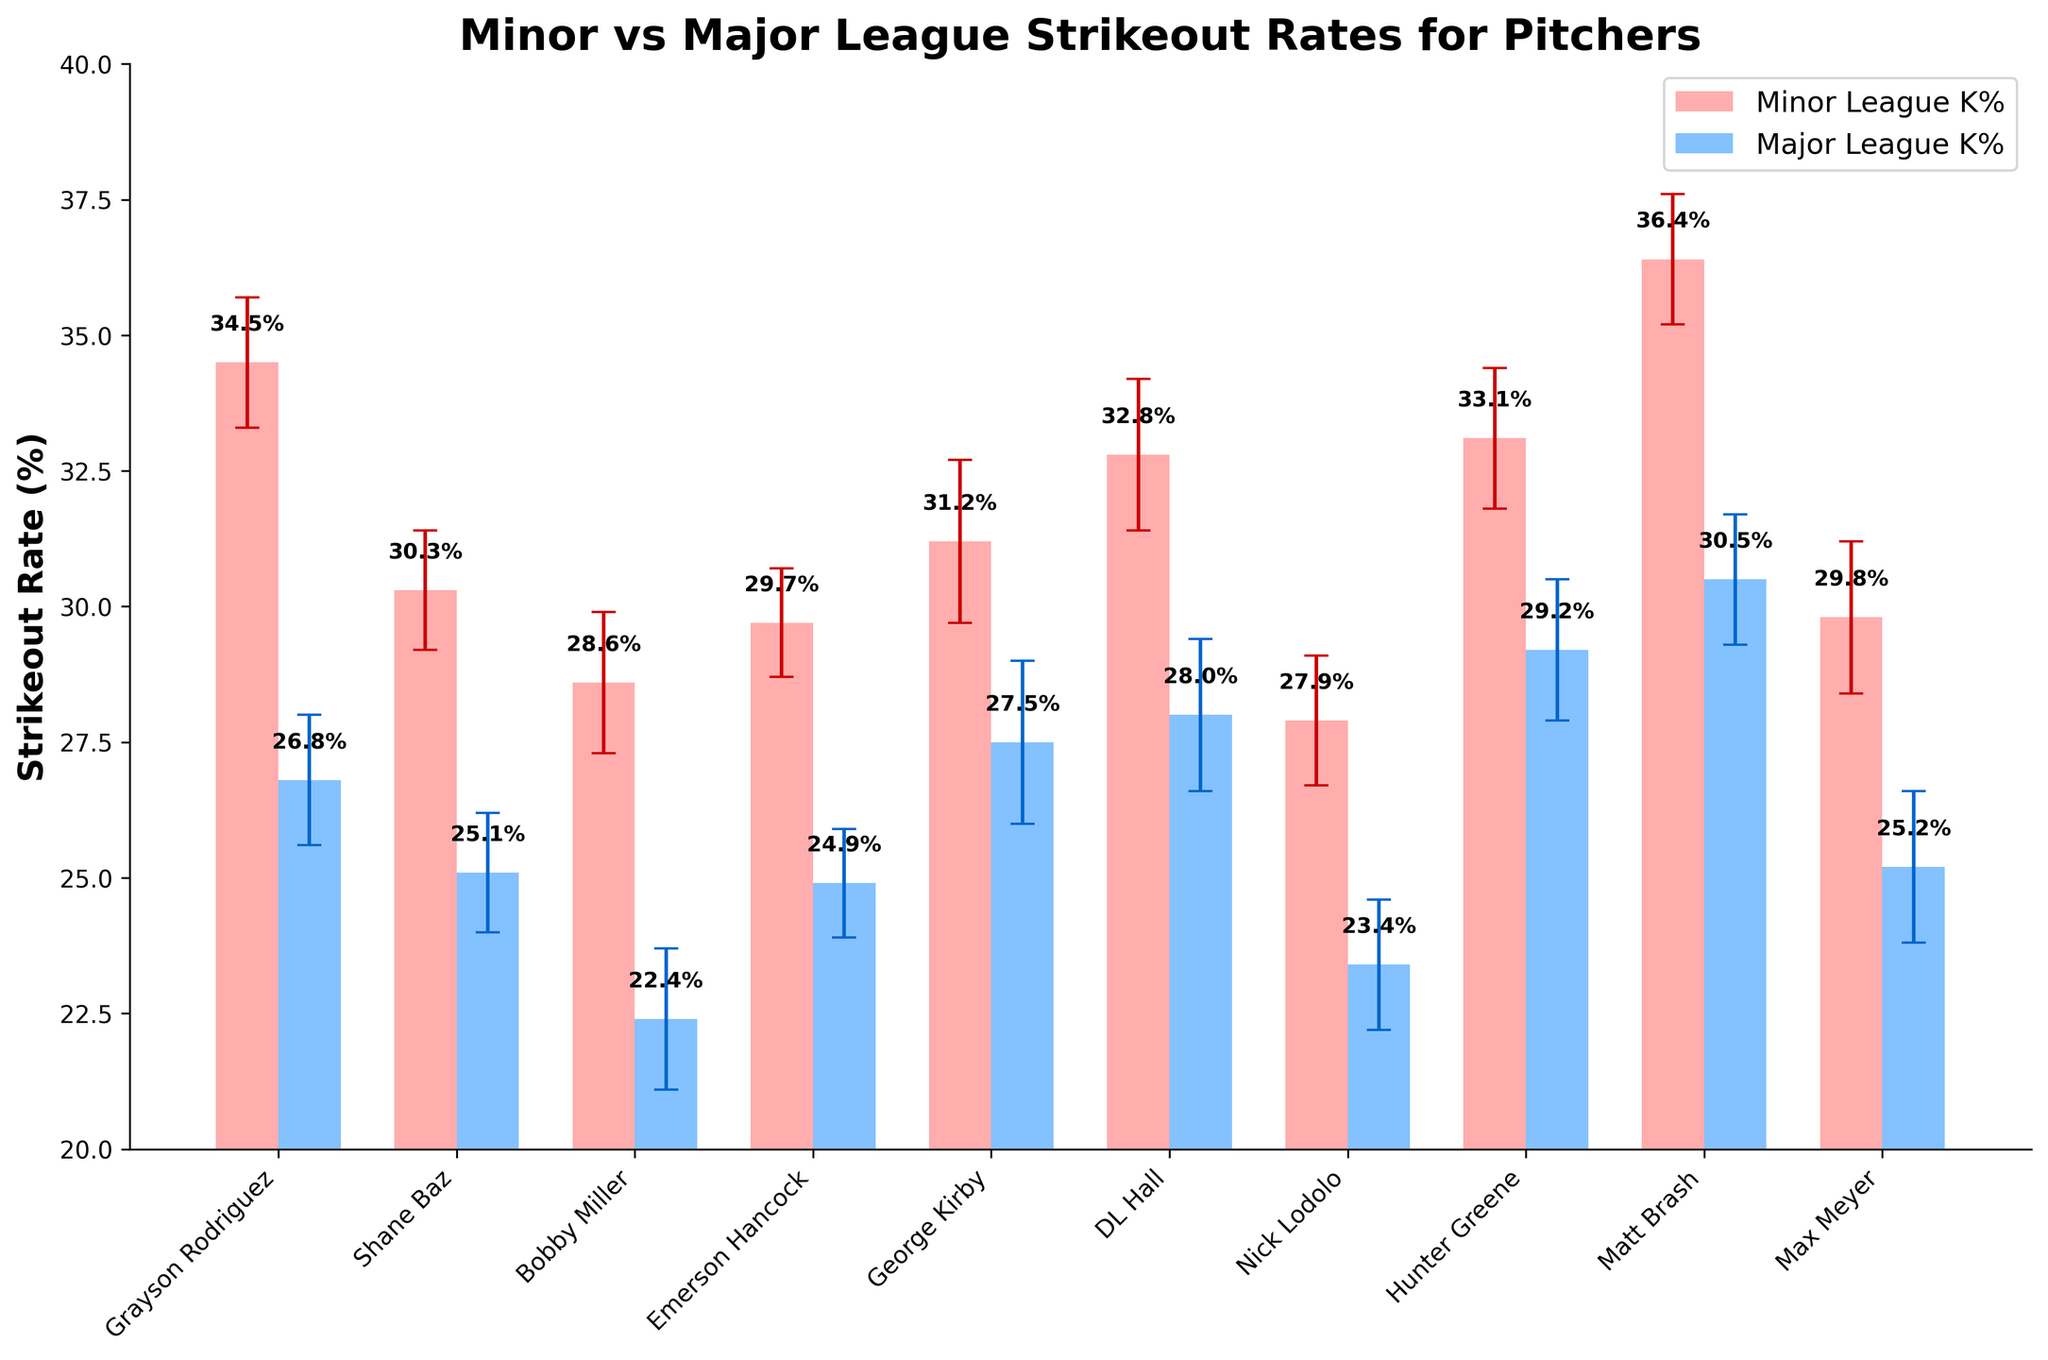Which pitcher had the highest Minor League strikeout rate? From the chart, look at the highest bar in the Minor League K% which represents Matt Brash, whose bar is the tallest among Minor League K% bars.
Answer: Matt Brash What is the difference in strikeout rate for Hunter Greene between Minor and Major League? Hunter Greene's Minor League K% is 33.1%, and his Major League K% is 29.2%. The difference is calculated by 33.1 - 29.2.
Answer: 3.9% Which league generally had higher strikeout rates for the pitchers shown? By comparing the heights of the bars, it is evident most Minor League bars are taller than Major League bars indicating higher Minor League strikeout rates.
Answer: Minor League Who had the smallest decline in strikeout rate when transitioning to the Major League? Calculate the differences for each pitcher between their Minor League and Major League K%. George Kirby had a decline from 31.2% to 27.5%, which is only a 3.7% drop, the smallest among all.
Answer: George Kirby How many pitchers had a Major League strikeout rate above 25%? Identify which Major League K% bars are above 25% by counting them: Grayson Rodriguez, Shane Baz, Emerson Hancock, George Kirby, DL Hall, Hunter Greene, and Matt Brash.
Answer: 7 Which pitcher had the largest standard error? Check the error bars that represent the standard error and find the longest one, which is for George Kirby.
Answer: George Kirby What is the average strikeout rate decrease for all pitchers in the Major League? Calculate the difference for each pitcher first and then find their average: (7.7 + 5.2 + 6.2 + 4.8 + 3.7 + 4.8 + 4.5 + 3.9 + 5.9 + 4.6) / 10.
Answer: 5.13% Did any pitcher have an increased strikeout rate in the transition to the Major League? Evaluate all comparisons visually; there is no instance where a Major League K% bar is taller than its corresponding Minor League K% bar.
Answer: No 